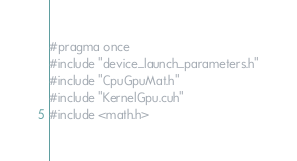Convert code to text. <code><loc_0><loc_0><loc_500><loc_500><_Cuda_>#pragma once
#include "device_launch_parameters.h"
#include "CpuGpuMat.h"
#include "KernelGpu.cuh"
#include <math.h>

</code> 